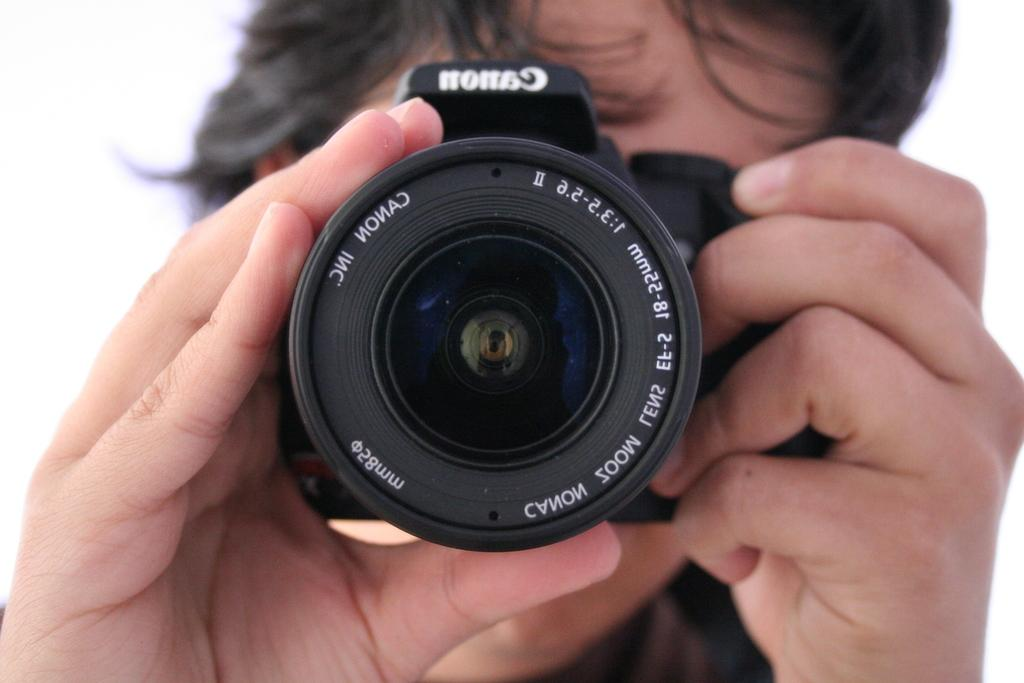Who is holding the camera in the image? There is a person holding the camera in the image. What can be seen on the camera? There is text on the camera. What is the color of the background in the image? The background in the image is white. What type of yarn is being used to create the limit in the image? There is no yarn or limit present in the image; it only features a person holding a camera with text on it and a white background. 